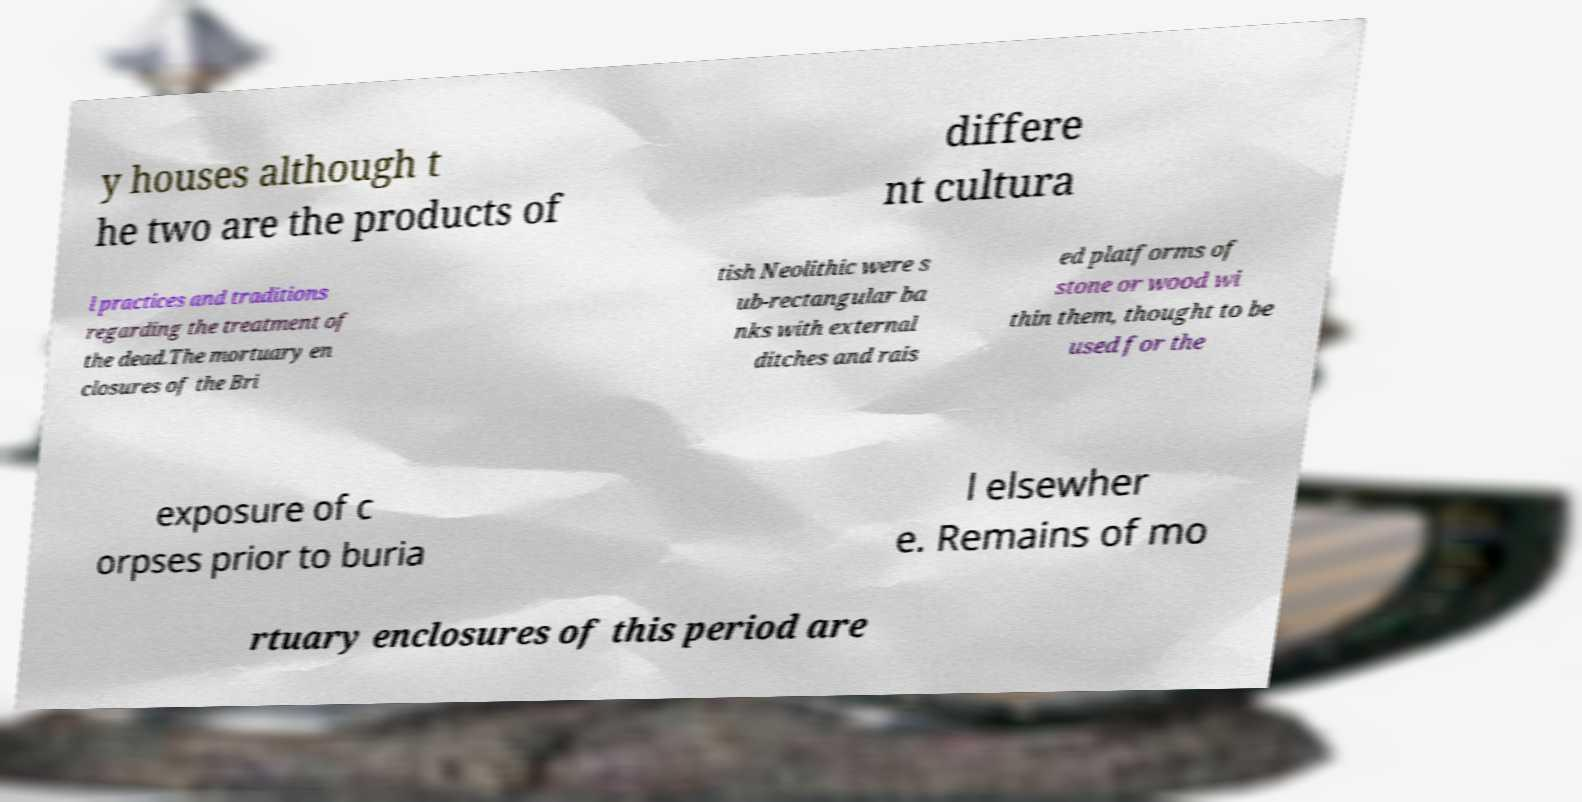Please identify and transcribe the text found in this image. y houses although t he two are the products of differe nt cultura l practices and traditions regarding the treatment of the dead.The mortuary en closures of the Bri tish Neolithic were s ub-rectangular ba nks with external ditches and rais ed platforms of stone or wood wi thin them, thought to be used for the exposure of c orpses prior to buria l elsewher e. Remains of mo rtuary enclosures of this period are 